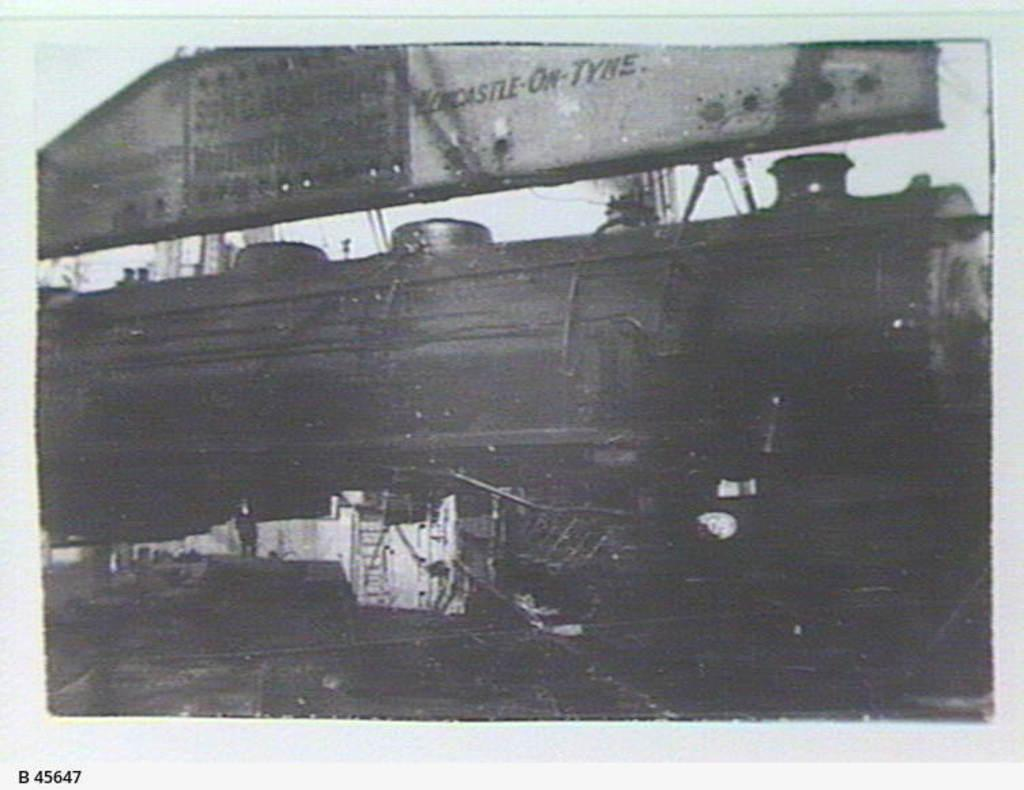What is present in the image that contains images and text? There is a poster in the image that contains images and text. Can you describe the images on the poster? The provided facts do not specify the images on the poster, so we cannot describe them. Where is the text located on the poster? The text is located on the bottom left corner of the poster. What type of beef is being served at the club in the image? There is no mention of beef, a club, or any serving of food in the image. The image only contains a poster with images and text. 